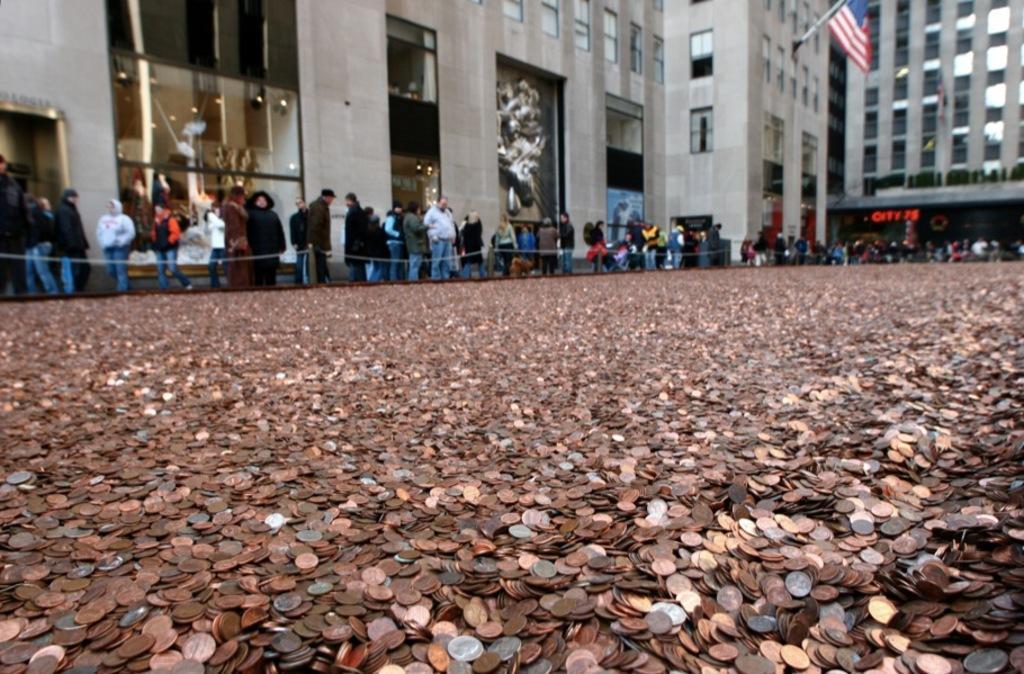Please provide a concise description of this image. In this picture we can see coins, there are some people standing and some people are walking in the middle, in the background we can see buildings, a flag and glasses. 